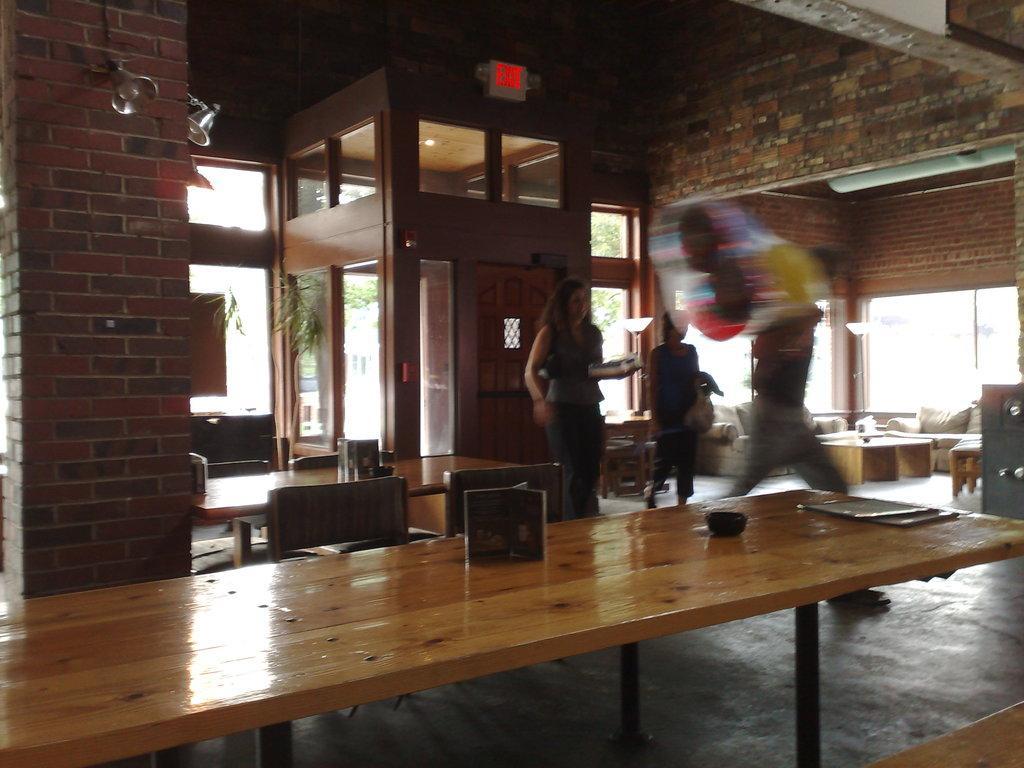How would you summarize this image in a sentence or two? In this image I can see a table,chair and three persons. 